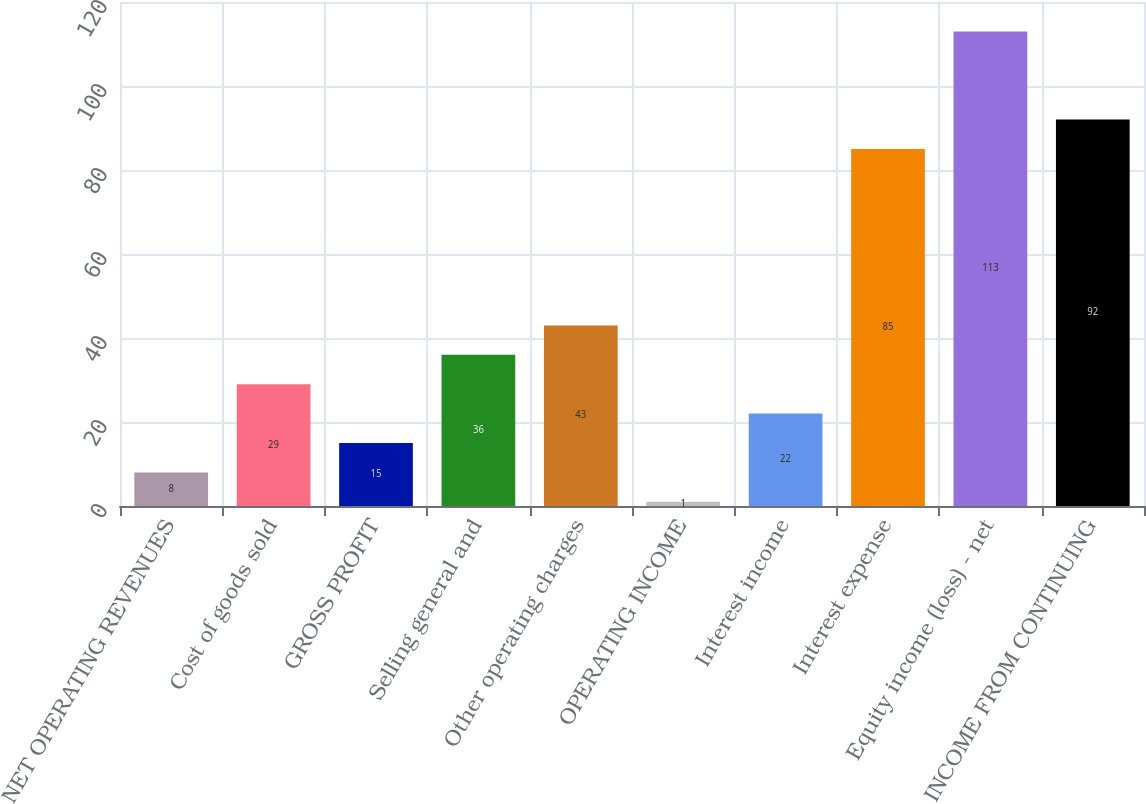Convert chart. <chart><loc_0><loc_0><loc_500><loc_500><bar_chart><fcel>NET OPERATING REVENUES<fcel>Cost of goods sold<fcel>GROSS PROFIT<fcel>Selling general and<fcel>Other operating charges<fcel>OPERATING INCOME<fcel>Interest income<fcel>Interest expense<fcel>Equity income (loss) - net<fcel>INCOME FROM CONTINUING<nl><fcel>8<fcel>29<fcel>15<fcel>36<fcel>43<fcel>1<fcel>22<fcel>85<fcel>113<fcel>92<nl></chart> 